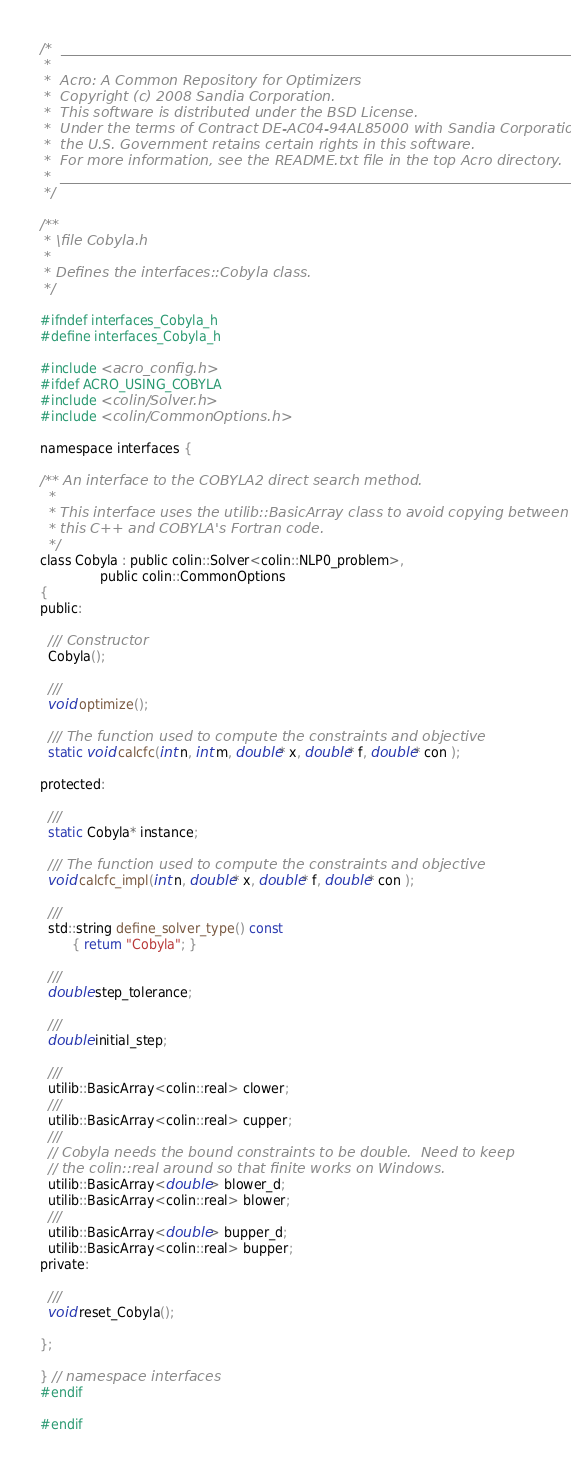<code> <loc_0><loc_0><loc_500><loc_500><_C_>/*  _________________________________________________________________________
 *
 *  Acro: A Common Repository for Optimizers
 *  Copyright (c) 2008 Sandia Corporation.
 *  This software is distributed under the BSD License.
 *  Under the terms of Contract DE-AC04-94AL85000 with Sandia Corporation,
 *  the U.S. Government retains certain rights in this software.
 *  For more information, see the README.txt file in the top Acro directory.
 *  _________________________________________________________________________
 */

/**
 * \file Cobyla.h
 *
 * Defines the interfaces::Cobyla class.
 */

#ifndef interfaces_Cobyla_h
#define interfaces_Cobyla_h

#include <acro_config.h>
#ifdef ACRO_USING_COBYLA
#include <colin/Solver.h>
#include <colin/CommonOptions.h>

namespace interfaces {

/** An interface to the COBYLA2 direct search method.
  *
  * This interface uses the utilib::BasicArray class to avoid copying between
  * this C++ and COBYLA's Fortran code.
  */
class Cobyla : public colin::Solver<colin::NLP0_problem>, 
               public colin::CommonOptions
{
public:

  /// Constructor
  Cobyla();

  ///
  void optimize();

  /// The function used to compute the constraints and objective
  static void calcfc(int n, int m, double* x, double* f, double* con );

protected:

  ///
  static Cobyla* instance;

  /// The function used to compute the constraints and objective
  void calcfc_impl(int n, double* x, double* f, double* con );

  ///
  std::string define_solver_type() const
        { return "Cobyla"; }

  ///
  double step_tolerance;

  ///
  double initial_step;

  ///
  utilib::BasicArray<colin::real> clower;
  ///
  utilib::BasicArray<colin::real> cupper;
  ///
  // Cobyla needs the bound constraints to be double.  Need to keep
  // the colin::real around so that finite works on Windows.
  utilib::BasicArray<double> blower_d;
  utilib::BasicArray<colin::real> blower;
  ///
  utilib::BasicArray<double> bupper_d;
  utilib::BasicArray<colin::real> bupper;
private:

  ///
  void reset_Cobyla();

};

} // namespace interfaces
#endif

#endif
</code> 